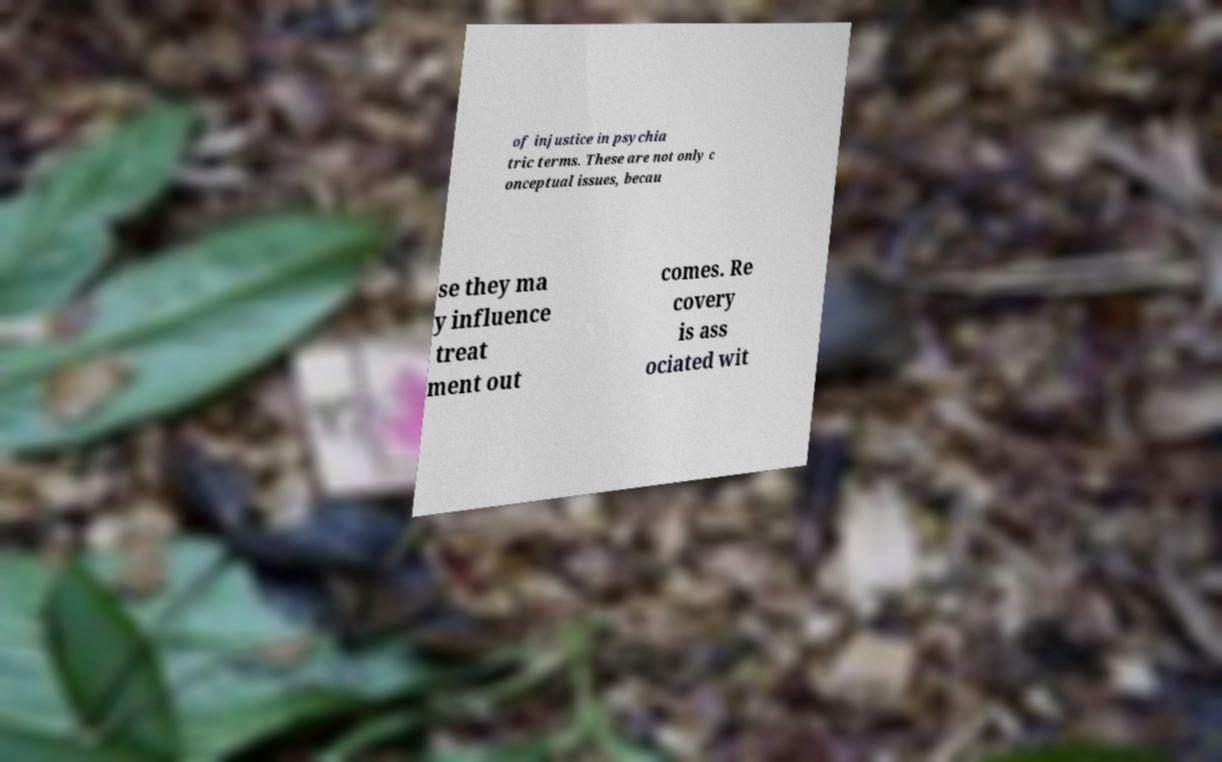Could you assist in decoding the text presented in this image and type it out clearly? of injustice in psychia tric terms. These are not only c onceptual issues, becau se they ma y influence treat ment out comes. Re covery is ass ociated wit 